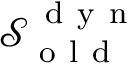<formula> <loc_0><loc_0><loc_500><loc_500>\mathcal { S } _ { o l d } ^ { d y n }</formula> 